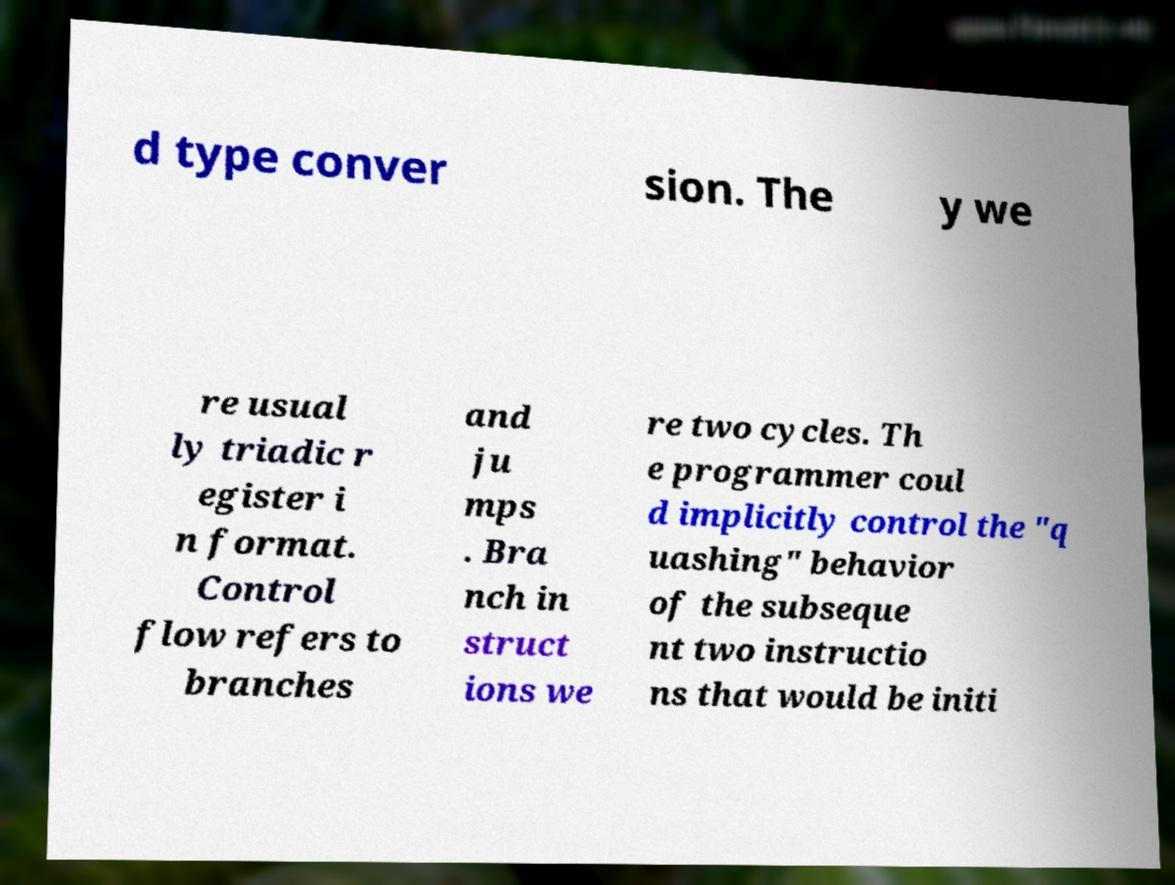I need the written content from this picture converted into text. Can you do that? d type conver sion. The y we re usual ly triadic r egister i n format. Control flow refers to branches and ju mps . Bra nch in struct ions we re two cycles. Th e programmer coul d implicitly control the "q uashing" behavior of the subseque nt two instructio ns that would be initi 